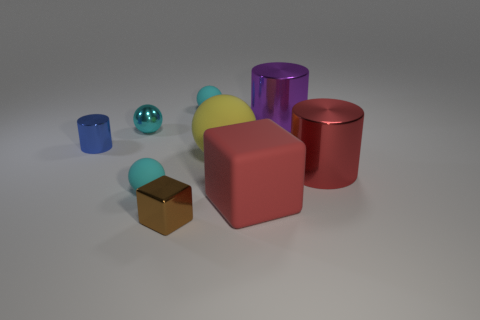How many cyan spheres must be subtracted to get 1 cyan spheres? 2 Add 1 red matte cubes. How many objects exist? 10 Subtract all large cylinders. How many cylinders are left? 1 Subtract all cylinders. How many objects are left? 6 Subtract 2 blocks. How many blocks are left? 0 Subtract all brown cylinders. How many cyan spheres are left? 3 Add 3 matte blocks. How many matte blocks are left? 4 Add 2 metallic blocks. How many metallic blocks exist? 3 Subtract all cyan spheres. How many spheres are left? 1 Subtract 0 blue cubes. How many objects are left? 9 